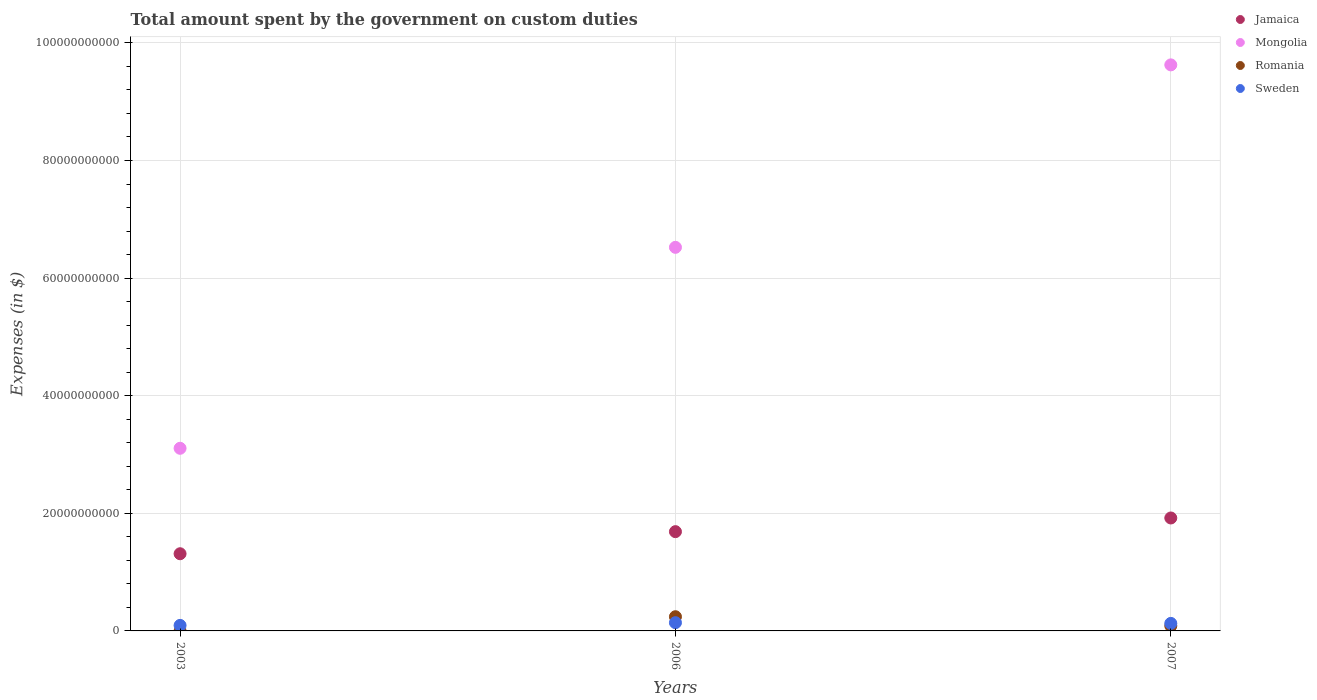Is the number of dotlines equal to the number of legend labels?
Keep it short and to the point. Yes. What is the amount spent on custom duties by the government in Jamaica in 2003?
Provide a succinct answer. 1.31e+1. Across all years, what is the maximum amount spent on custom duties by the government in Sweden?
Provide a succinct answer. 1.40e+09. Across all years, what is the minimum amount spent on custom duties by the government in Mongolia?
Your answer should be very brief. 3.11e+1. In which year was the amount spent on custom duties by the government in Mongolia minimum?
Provide a short and direct response. 2003. What is the total amount spent on custom duties by the government in Sweden in the graph?
Your answer should be very brief. 3.62e+09. What is the difference between the amount spent on custom duties by the government in Sweden in 2003 and that in 2007?
Give a very brief answer. -3.41e+08. What is the difference between the amount spent on custom duties by the government in Romania in 2003 and the amount spent on custom duties by the government in Sweden in 2007?
Provide a succinct answer. -1.27e+09. What is the average amount spent on custom duties by the government in Mongolia per year?
Give a very brief answer. 6.42e+1. In the year 2006, what is the difference between the amount spent on custom duties by the government in Jamaica and amount spent on custom duties by the government in Mongolia?
Give a very brief answer. -4.84e+1. What is the ratio of the amount spent on custom duties by the government in Jamaica in 2006 to that in 2007?
Provide a short and direct response. 0.88. What is the difference between the highest and the second highest amount spent on custom duties by the government in Romania?
Provide a short and direct response. 1.56e+09. What is the difference between the highest and the lowest amount spent on custom duties by the government in Romania?
Offer a terse response. 2.41e+09. In how many years, is the amount spent on custom duties by the government in Sweden greater than the average amount spent on custom duties by the government in Sweden taken over all years?
Ensure brevity in your answer.  2. Is the sum of the amount spent on custom duties by the government in Sweden in 2003 and 2006 greater than the maximum amount spent on custom duties by the government in Jamaica across all years?
Your response must be concise. No. Is it the case that in every year, the sum of the amount spent on custom duties by the government in Jamaica and amount spent on custom duties by the government in Sweden  is greater than the sum of amount spent on custom duties by the government in Romania and amount spent on custom duties by the government in Mongolia?
Your answer should be compact. No. Is it the case that in every year, the sum of the amount spent on custom duties by the government in Sweden and amount spent on custom duties by the government in Romania  is greater than the amount spent on custom duties by the government in Jamaica?
Offer a terse response. No. Does the amount spent on custom duties by the government in Sweden monotonically increase over the years?
Offer a very short reply. No. Is the amount spent on custom duties by the government in Jamaica strictly greater than the amount spent on custom duties by the government in Sweden over the years?
Give a very brief answer. Yes. Is the amount spent on custom duties by the government in Romania strictly less than the amount spent on custom duties by the government in Jamaica over the years?
Give a very brief answer. Yes. How many years are there in the graph?
Provide a succinct answer. 3. Are the values on the major ticks of Y-axis written in scientific E-notation?
Your response must be concise. No. Where does the legend appear in the graph?
Your answer should be compact. Top right. How many legend labels are there?
Your response must be concise. 4. How are the legend labels stacked?
Offer a very short reply. Vertical. What is the title of the graph?
Ensure brevity in your answer.  Total amount spent by the government on custom duties. Does "Mauritania" appear as one of the legend labels in the graph?
Offer a terse response. No. What is the label or title of the Y-axis?
Provide a short and direct response. Expenses (in $). What is the Expenses (in $) of Jamaica in 2003?
Your answer should be compact. 1.31e+1. What is the Expenses (in $) in Mongolia in 2003?
Provide a succinct answer. 3.11e+1. What is the Expenses (in $) of Romania in 2003?
Offer a very short reply. 5.31e+06. What is the Expenses (in $) in Sweden in 2003?
Your response must be concise. 9.39e+08. What is the Expenses (in $) of Jamaica in 2006?
Provide a short and direct response. 1.69e+1. What is the Expenses (in $) of Mongolia in 2006?
Provide a succinct answer. 6.52e+1. What is the Expenses (in $) of Romania in 2006?
Ensure brevity in your answer.  2.41e+09. What is the Expenses (in $) of Sweden in 2006?
Your answer should be very brief. 1.40e+09. What is the Expenses (in $) of Jamaica in 2007?
Keep it short and to the point. 1.92e+1. What is the Expenses (in $) of Mongolia in 2007?
Provide a short and direct response. 9.63e+1. What is the Expenses (in $) of Romania in 2007?
Offer a terse response. 8.56e+08. What is the Expenses (in $) in Sweden in 2007?
Make the answer very short. 1.28e+09. Across all years, what is the maximum Expenses (in $) in Jamaica?
Offer a very short reply. 1.92e+1. Across all years, what is the maximum Expenses (in $) in Mongolia?
Offer a very short reply. 9.63e+1. Across all years, what is the maximum Expenses (in $) in Romania?
Make the answer very short. 2.41e+09. Across all years, what is the maximum Expenses (in $) in Sweden?
Keep it short and to the point. 1.40e+09. Across all years, what is the minimum Expenses (in $) in Jamaica?
Offer a very short reply. 1.31e+1. Across all years, what is the minimum Expenses (in $) of Mongolia?
Make the answer very short. 3.11e+1. Across all years, what is the minimum Expenses (in $) in Romania?
Offer a terse response. 5.31e+06. Across all years, what is the minimum Expenses (in $) of Sweden?
Provide a short and direct response. 9.39e+08. What is the total Expenses (in $) of Jamaica in the graph?
Offer a terse response. 4.92e+1. What is the total Expenses (in $) of Mongolia in the graph?
Ensure brevity in your answer.  1.93e+11. What is the total Expenses (in $) of Romania in the graph?
Give a very brief answer. 3.28e+09. What is the total Expenses (in $) in Sweden in the graph?
Provide a succinct answer. 3.62e+09. What is the difference between the Expenses (in $) of Jamaica in 2003 and that in 2006?
Your answer should be very brief. -3.76e+09. What is the difference between the Expenses (in $) of Mongolia in 2003 and that in 2006?
Your response must be concise. -3.42e+1. What is the difference between the Expenses (in $) in Romania in 2003 and that in 2006?
Keep it short and to the point. -2.41e+09. What is the difference between the Expenses (in $) of Sweden in 2003 and that in 2006?
Keep it short and to the point. -4.61e+08. What is the difference between the Expenses (in $) of Jamaica in 2003 and that in 2007?
Your response must be concise. -6.08e+09. What is the difference between the Expenses (in $) of Mongolia in 2003 and that in 2007?
Ensure brevity in your answer.  -6.52e+1. What is the difference between the Expenses (in $) in Romania in 2003 and that in 2007?
Your answer should be compact. -8.50e+08. What is the difference between the Expenses (in $) in Sweden in 2003 and that in 2007?
Give a very brief answer. -3.41e+08. What is the difference between the Expenses (in $) in Jamaica in 2006 and that in 2007?
Offer a terse response. -2.33e+09. What is the difference between the Expenses (in $) in Mongolia in 2006 and that in 2007?
Provide a succinct answer. -3.10e+1. What is the difference between the Expenses (in $) in Romania in 2006 and that in 2007?
Offer a very short reply. 1.56e+09. What is the difference between the Expenses (in $) of Sweden in 2006 and that in 2007?
Provide a short and direct response. 1.20e+08. What is the difference between the Expenses (in $) in Jamaica in 2003 and the Expenses (in $) in Mongolia in 2006?
Provide a short and direct response. -5.21e+1. What is the difference between the Expenses (in $) in Jamaica in 2003 and the Expenses (in $) in Romania in 2006?
Offer a terse response. 1.07e+1. What is the difference between the Expenses (in $) of Jamaica in 2003 and the Expenses (in $) of Sweden in 2006?
Make the answer very short. 1.17e+1. What is the difference between the Expenses (in $) of Mongolia in 2003 and the Expenses (in $) of Romania in 2006?
Your answer should be very brief. 2.86e+1. What is the difference between the Expenses (in $) of Mongolia in 2003 and the Expenses (in $) of Sweden in 2006?
Give a very brief answer. 2.97e+1. What is the difference between the Expenses (in $) of Romania in 2003 and the Expenses (in $) of Sweden in 2006?
Offer a very short reply. -1.39e+09. What is the difference between the Expenses (in $) in Jamaica in 2003 and the Expenses (in $) in Mongolia in 2007?
Provide a succinct answer. -8.31e+1. What is the difference between the Expenses (in $) of Jamaica in 2003 and the Expenses (in $) of Romania in 2007?
Offer a very short reply. 1.23e+1. What is the difference between the Expenses (in $) in Jamaica in 2003 and the Expenses (in $) in Sweden in 2007?
Your answer should be very brief. 1.18e+1. What is the difference between the Expenses (in $) of Mongolia in 2003 and the Expenses (in $) of Romania in 2007?
Your answer should be very brief. 3.02e+1. What is the difference between the Expenses (in $) in Mongolia in 2003 and the Expenses (in $) in Sweden in 2007?
Offer a terse response. 2.98e+1. What is the difference between the Expenses (in $) of Romania in 2003 and the Expenses (in $) of Sweden in 2007?
Your answer should be very brief. -1.27e+09. What is the difference between the Expenses (in $) of Jamaica in 2006 and the Expenses (in $) of Mongolia in 2007?
Keep it short and to the point. -7.94e+1. What is the difference between the Expenses (in $) in Jamaica in 2006 and the Expenses (in $) in Romania in 2007?
Keep it short and to the point. 1.60e+1. What is the difference between the Expenses (in $) of Jamaica in 2006 and the Expenses (in $) of Sweden in 2007?
Offer a terse response. 1.56e+1. What is the difference between the Expenses (in $) in Mongolia in 2006 and the Expenses (in $) in Romania in 2007?
Make the answer very short. 6.44e+1. What is the difference between the Expenses (in $) in Mongolia in 2006 and the Expenses (in $) in Sweden in 2007?
Offer a terse response. 6.40e+1. What is the difference between the Expenses (in $) in Romania in 2006 and the Expenses (in $) in Sweden in 2007?
Provide a short and direct response. 1.13e+09. What is the average Expenses (in $) of Jamaica per year?
Your answer should be very brief. 1.64e+1. What is the average Expenses (in $) in Mongolia per year?
Offer a very short reply. 6.42e+1. What is the average Expenses (in $) of Romania per year?
Make the answer very short. 1.09e+09. What is the average Expenses (in $) in Sweden per year?
Offer a terse response. 1.21e+09. In the year 2003, what is the difference between the Expenses (in $) of Jamaica and Expenses (in $) of Mongolia?
Provide a short and direct response. -1.79e+1. In the year 2003, what is the difference between the Expenses (in $) of Jamaica and Expenses (in $) of Romania?
Offer a very short reply. 1.31e+1. In the year 2003, what is the difference between the Expenses (in $) of Jamaica and Expenses (in $) of Sweden?
Your response must be concise. 1.22e+1. In the year 2003, what is the difference between the Expenses (in $) in Mongolia and Expenses (in $) in Romania?
Provide a short and direct response. 3.11e+1. In the year 2003, what is the difference between the Expenses (in $) of Mongolia and Expenses (in $) of Sweden?
Your answer should be very brief. 3.01e+1. In the year 2003, what is the difference between the Expenses (in $) in Romania and Expenses (in $) in Sweden?
Provide a succinct answer. -9.34e+08. In the year 2006, what is the difference between the Expenses (in $) of Jamaica and Expenses (in $) of Mongolia?
Give a very brief answer. -4.84e+1. In the year 2006, what is the difference between the Expenses (in $) of Jamaica and Expenses (in $) of Romania?
Provide a succinct answer. 1.45e+1. In the year 2006, what is the difference between the Expenses (in $) of Jamaica and Expenses (in $) of Sweden?
Offer a terse response. 1.55e+1. In the year 2006, what is the difference between the Expenses (in $) in Mongolia and Expenses (in $) in Romania?
Give a very brief answer. 6.28e+1. In the year 2006, what is the difference between the Expenses (in $) of Mongolia and Expenses (in $) of Sweden?
Give a very brief answer. 6.38e+1. In the year 2006, what is the difference between the Expenses (in $) of Romania and Expenses (in $) of Sweden?
Ensure brevity in your answer.  1.01e+09. In the year 2007, what is the difference between the Expenses (in $) in Jamaica and Expenses (in $) in Mongolia?
Offer a terse response. -7.71e+1. In the year 2007, what is the difference between the Expenses (in $) in Jamaica and Expenses (in $) in Romania?
Give a very brief answer. 1.84e+1. In the year 2007, what is the difference between the Expenses (in $) of Jamaica and Expenses (in $) of Sweden?
Your response must be concise. 1.79e+1. In the year 2007, what is the difference between the Expenses (in $) of Mongolia and Expenses (in $) of Romania?
Give a very brief answer. 9.54e+1. In the year 2007, what is the difference between the Expenses (in $) of Mongolia and Expenses (in $) of Sweden?
Offer a terse response. 9.50e+1. In the year 2007, what is the difference between the Expenses (in $) of Romania and Expenses (in $) of Sweden?
Provide a succinct answer. -4.24e+08. What is the ratio of the Expenses (in $) of Jamaica in 2003 to that in 2006?
Give a very brief answer. 0.78. What is the ratio of the Expenses (in $) in Mongolia in 2003 to that in 2006?
Make the answer very short. 0.48. What is the ratio of the Expenses (in $) in Romania in 2003 to that in 2006?
Keep it short and to the point. 0. What is the ratio of the Expenses (in $) of Sweden in 2003 to that in 2006?
Provide a short and direct response. 0.67. What is the ratio of the Expenses (in $) of Jamaica in 2003 to that in 2007?
Ensure brevity in your answer.  0.68. What is the ratio of the Expenses (in $) of Mongolia in 2003 to that in 2007?
Ensure brevity in your answer.  0.32. What is the ratio of the Expenses (in $) of Romania in 2003 to that in 2007?
Your answer should be compact. 0.01. What is the ratio of the Expenses (in $) in Sweden in 2003 to that in 2007?
Ensure brevity in your answer.  0.73. What is the ratio of the Expenses (in $) of Jamaica in 2006 to that in 2007?
Ensure brevity in your answer.  0.88. What is the ratio of the Expenses (in $) in Mongolia in 2006 to that in 2007?
Offer a very short reply. 0.68. What is the ratio of the Expenses (in $) of Romania in 2006 to that in 2007?
Ensure brevity in your answer.  2.82. What is the ratio of the Expenses (in $) of Sweden in 2006 to that in 2007?
Offer a very short reply. 1.09. What is the difference between the highest and the second highest Expenses (in $) of Jamaica?
Your answer should be very brief. 2.33e+09. What is the difference between the highest and the second highest Expenses (in $) of Mongolia?
Keep it short and to the point. 3.10e+1. What is the difference between the highest and the second highest Expenses (in $) of Romania?
Offer a terse response. 1.56e+09. What is the difference between the highest and the second highest Expenses (in $) in Sweden?
Provide a short and direct response. 1.20e+08. What is the difference between the highest and the lowest Expenses (in $) in Jamaica?
Provide a succinct answer. 6.08e+09. What is the difference between the highest and the lowest Expenses (in $) in Mongolia?
Your answer should be very brief. 6.52e+1. What is the difference between the highest and the lowest Expenses (in $) in Romania?
Your response must be concise. 2.41e+09. What is the difference between the highest and the lowest Expenses (in $) in Sweden?
Provide a succinct answer. 4.61e+08. 